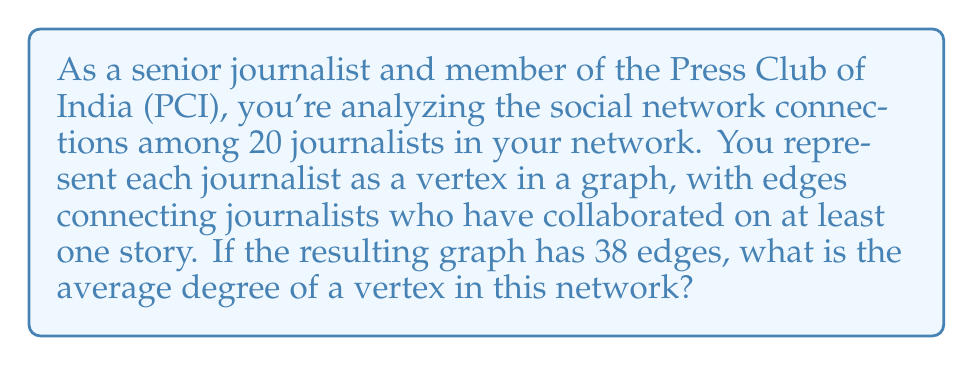Could you help me with this problem? Let's approach this step-by-step using concepts from graph theory:

1) First, recall the Handshaking Lemma, which states that in an undirected graph:

   $$\sum_{v \in V} \deg(v) = 2|E|$$

   where $V$ is the set of vertices, $\deg(v)$ is the degree of vertex $v$, and $|E|$ is the number of edges.

2) In this case, we have:
   - Number of vertices $|V| = 20$ (representing 20 journalists)
   - Number of edges $|E| = 38$

3) Applying the Handshaking Lemma:

   $$\sum_{v \in V} \deg(v) = 2 \times 38 = 76$$

4) The average degree of a vertex is the total degree sum divided by the number of vertices:

   $$\text{Average Degree} = \frac{\sum_{v \in V} \deg(v)}{|V|} = \frac{76}{20} = 3.8$$

Thus, on average, each journalist in your network has collaborated with 3.8 other journalists.
Answer: The average degree of a vertex in this network is 3.8. 